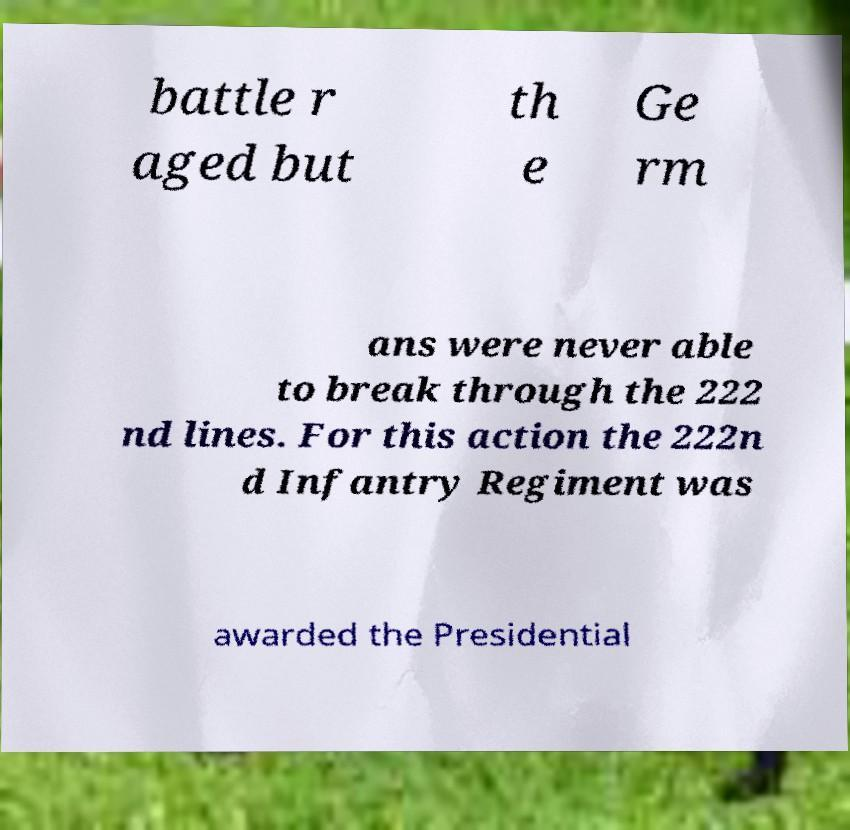There's text embedded in this image that I need extracted. Can you transcribe it verbatim? battle r aged but th e Ge rm ans were never able to break through the 222 nd lines. For this action the 222n d Infantry Regiment was awarded the Presidential 